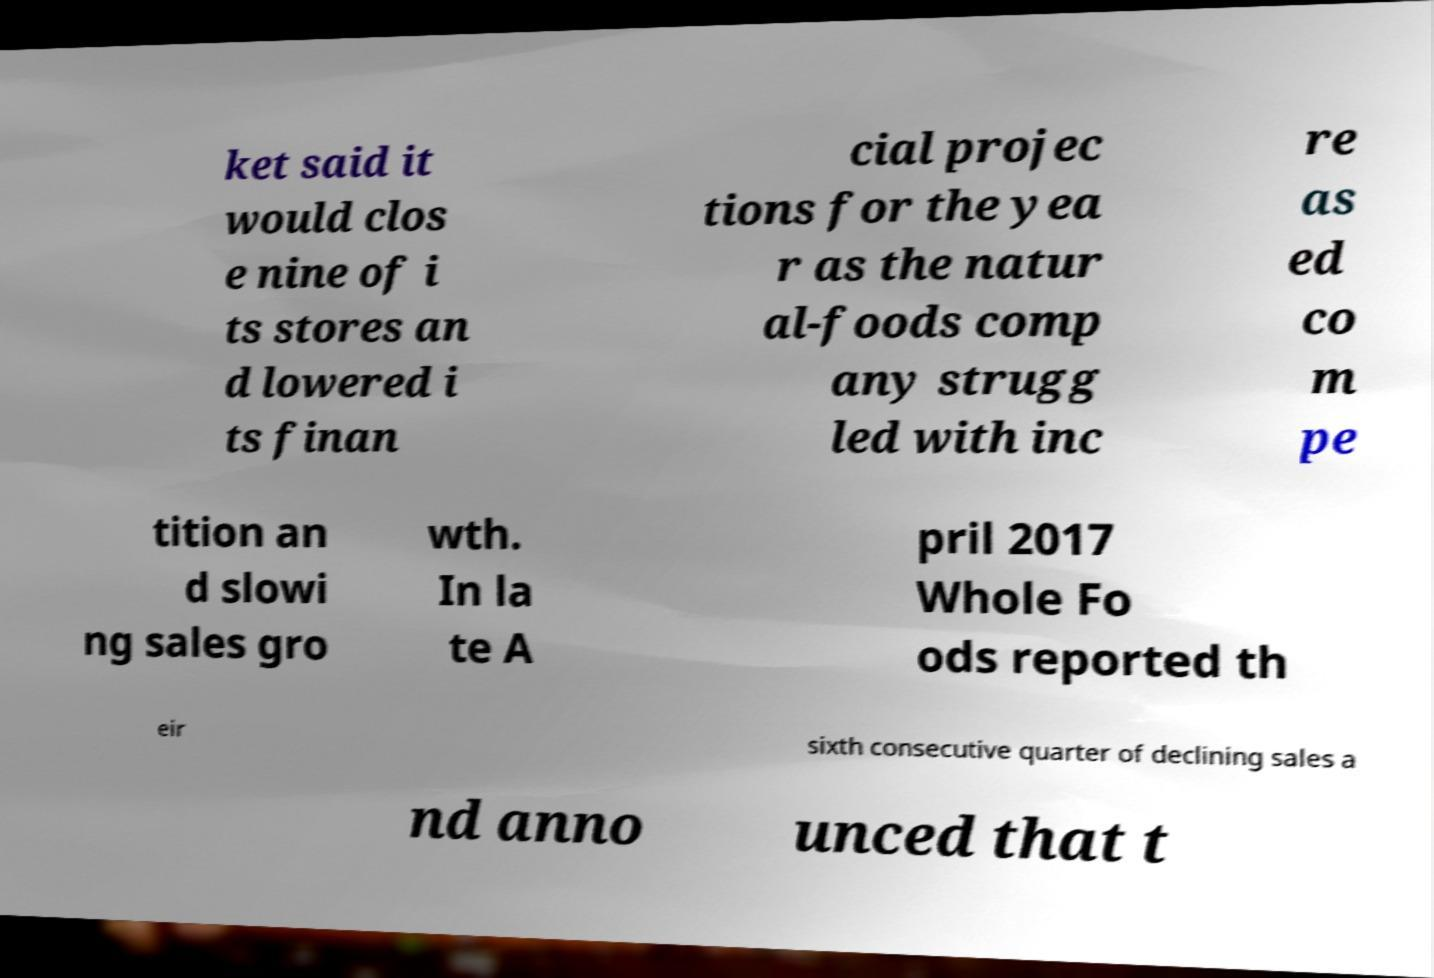What messages or text are displayed in this image? I need them in a readable, typed format. ket said it would clos e nine of i ts stores an d lowered i ts finan cial projec tions for the yea r as the natur al-foods comp any strugg led with inc re as ed co m pe tition an d slowi ng sales gro wth. In la te A pril 2017 Whole Fo ods reported th eir sixth consecutive quarter of declining sales a nd anno unced that t 